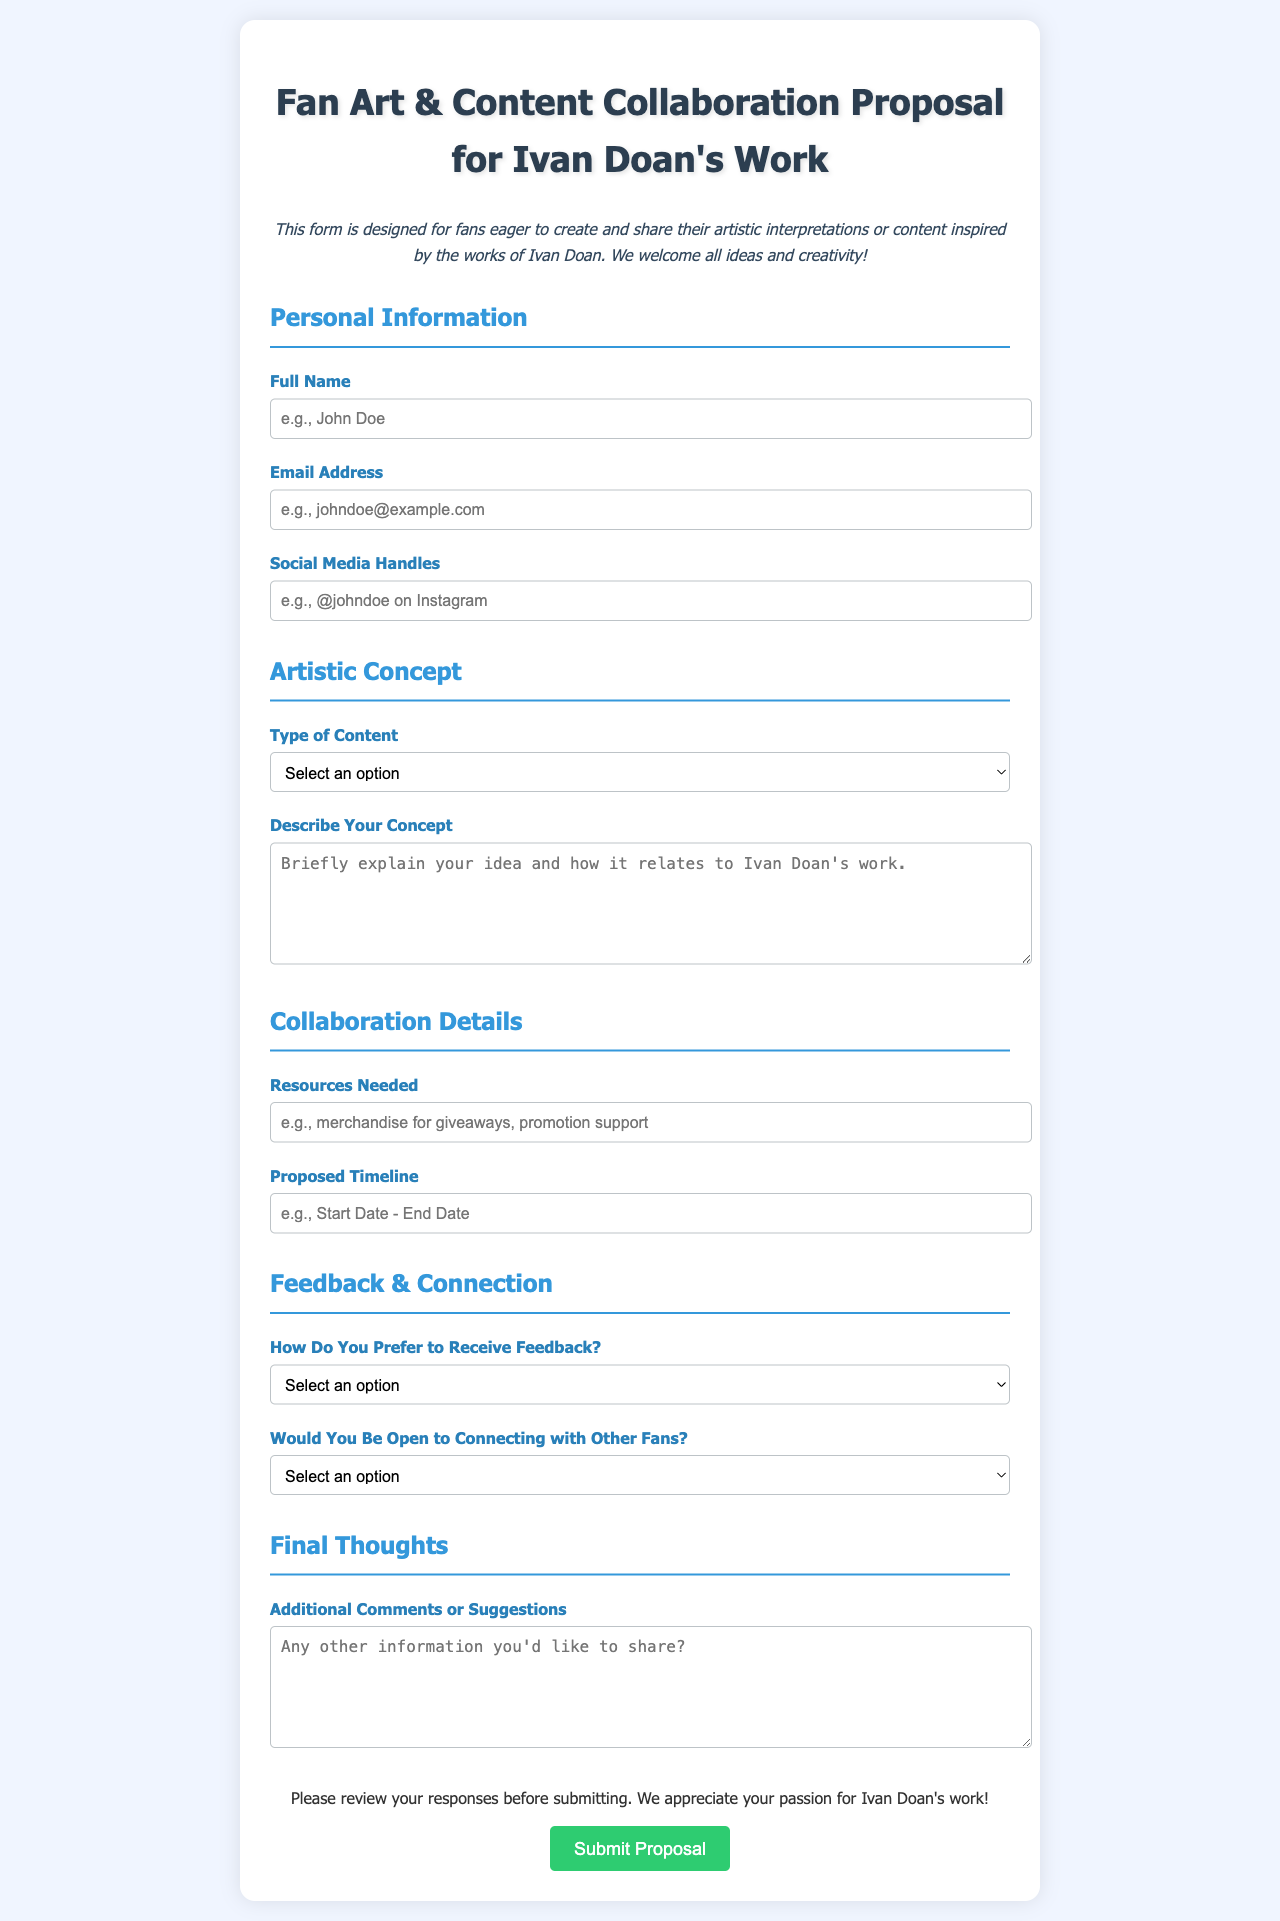What is the title of the document? The title of the document is displayed prominently at the top of the page.
Answer: Fan Art & Content Collaboration Proposal for Ivan Doan's Work How many types of content can be selected? The document lists various options for the type of content and counts them.
Answer: Five What is the proposed timeline placeholder example? The form provides hints in the input fields to guide users on what to enter.
Answer: Start Date - End Date What is the color of the submit button? The document specifies the color style used for the submit button.
Answer: Green How does the form suggest fans describe their artistic concept? The form includes a textarea for detailed explanations, indicating the type of response needed.
Answer: Briefly explain your idea and how it relates to Ivan Doan's work What is the label for the optional social media input? The document provides a specific label for this information field.
Answer: Social Media Handles Is there a section for additional comments? The structure of the document indicates there is a section for extra feedback.
Answer: Yes What are the available options for receiving feedback? The document outlines multiple choices provided in a dropdown menu.
Answer: Email, Social Media Direct Messages, Public Forum, Other Would fans be able to connect with other fans? The collaboration section contains choices indicating willingness to connect with others.
Answer: Yes, absolutely! or Maybe or No 